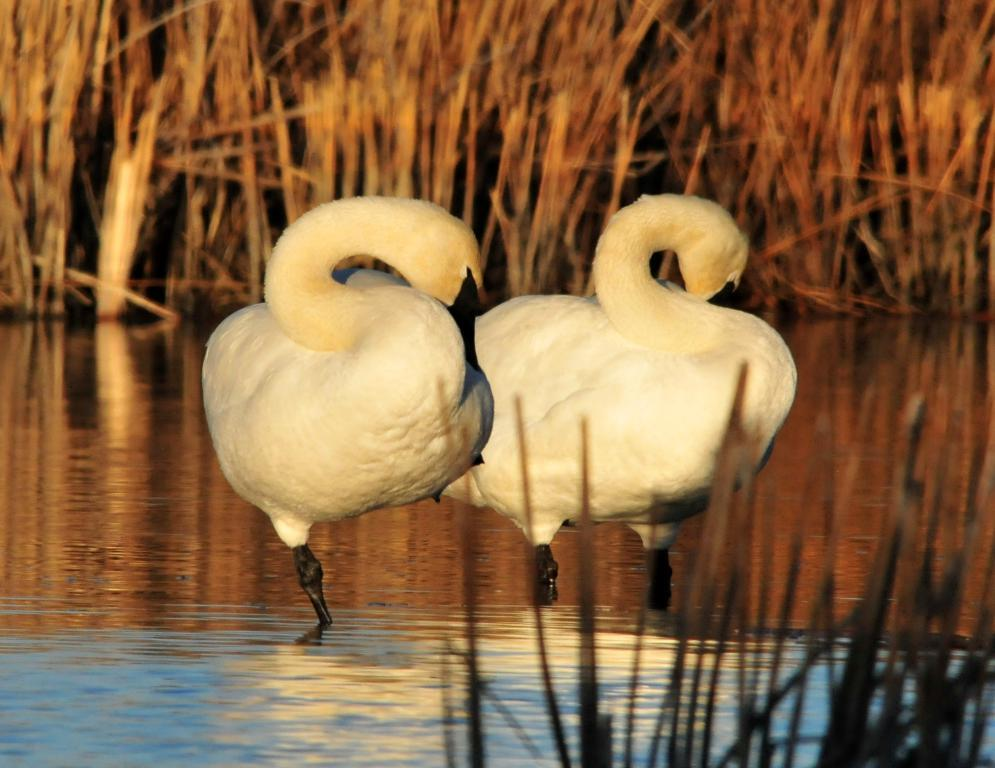How many birds are present in the image? There are two birds in the image. What is the position of the birds in the image? The birds are standing in the water. What type of vegetation is visible in the image? There is grass visible in the image. Can you see a bike being ridden by one of the birds in the image? There is no bike present in the image, and the birds are standing in the water, not riding a bike. 